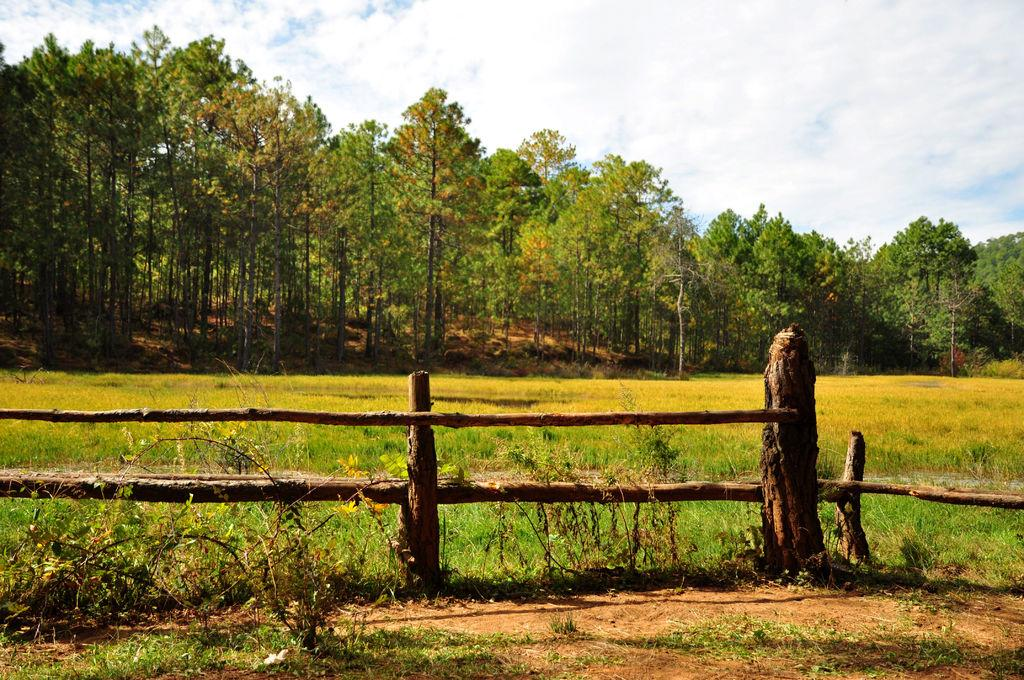What type of vegetation can be seen in the image? There is grass in the image. What else can be observed in the image besides the grass? Shadows, trees, clouds, and the sky are visible in the image. Can you describe the shadows in the image? The shadows suggest that there is a light source, such as the sun, casting shadows on the ground objects. What is the condition of the sky in the image? The sky is visible in the image, and clouds are present. What type of rice can be seen growing in the image? There is no rice present in the image; it features grass, shadows, trees, clouds, and the sky. How does the wind blow the clouds in the image? The image does not depict the wind blowing the clouds; it simply shows clouds in the sky. 